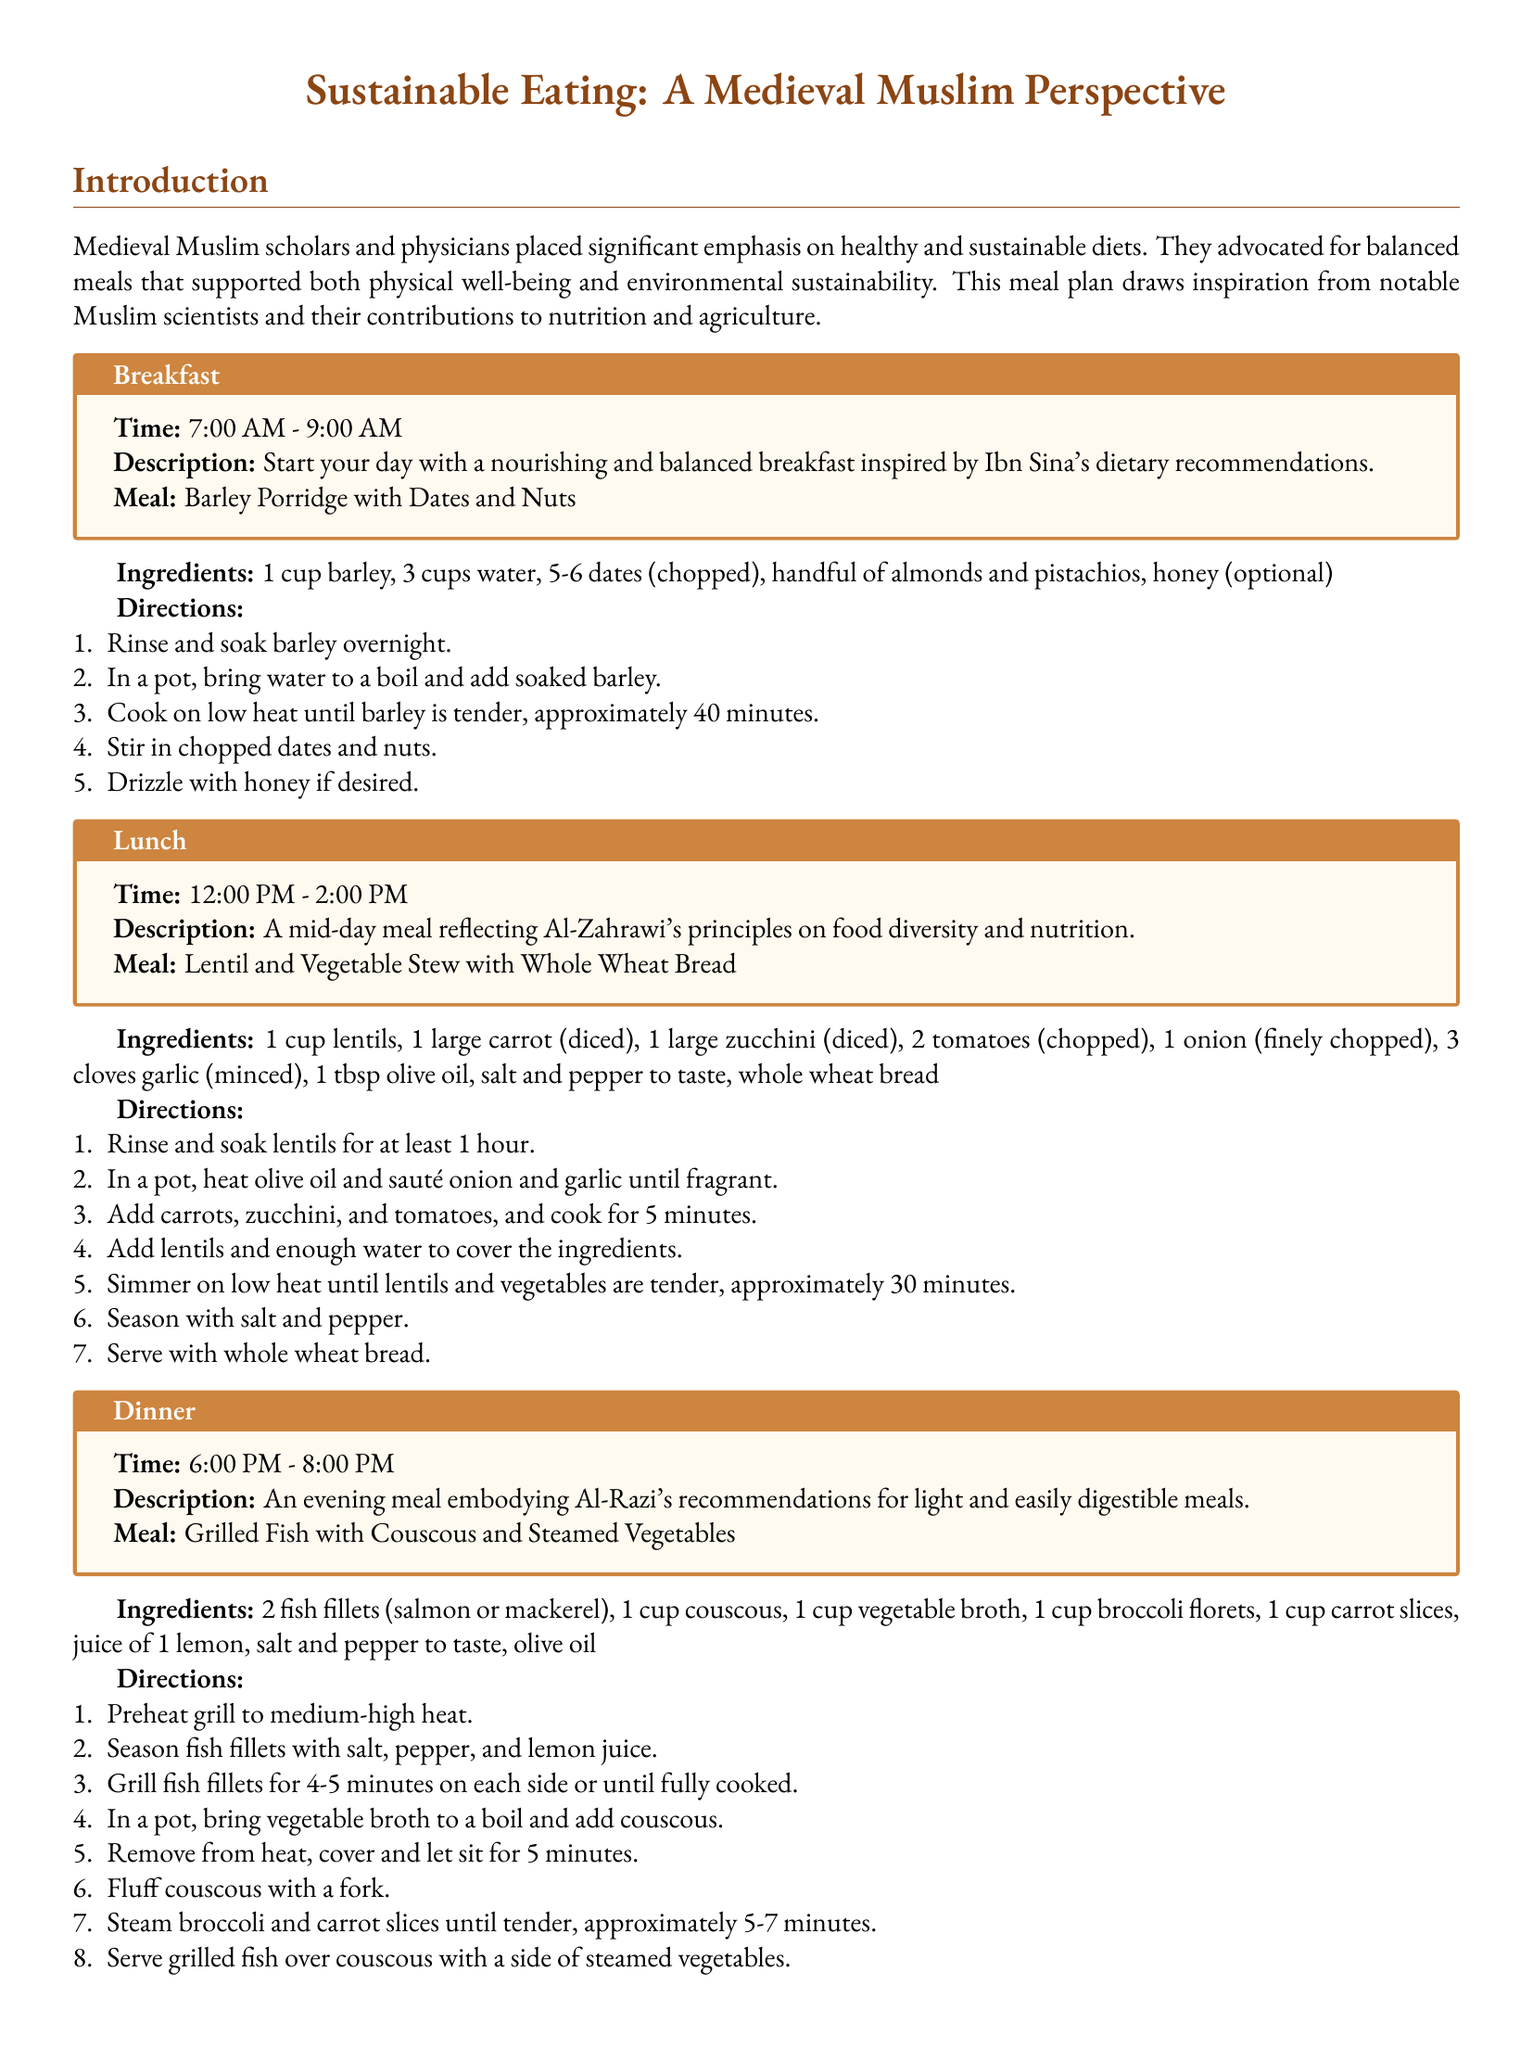what is the first meal of the day? The meal plan begins with breakfast, which is specified as the first meal of the day.
Answer: Barley Porridge with Dates and Nuts who is the scholar associated with the lunch meal? The lunch meal is reflective of Al-Zahrawi's principles on food diversity and nutrition, mentioned in the document.
Answer: Al-Zahrawi what time is dinner served? The document specifies that dinner is served between 6:00 PM and 8:00 PM.
Answer: 6:00 PM - 8:00 PM how long should lentils be soaked before cooking? The document states that lentils should be rinsed and soaked for at least 1 hour before cooking.
Answer: 1 hour which fish are recommended for the dinner meal? The document lists the types of fish that can be used for the dinner meal.
Answer: salmon or mackerel what type of bread is served with lunch? The lunch meal description specifies the type of bread accompanying the meal.
Answer: whole wheat bread which ingredient is optional for breakfast? The document indicates that one of the ingredients for breakfast can be omitted or included based on preference.
Answer: honey what is the total cooking time for barley porridge? The document states that barley should be cooked until tender, which takes approximately 40 minutes.
Answer: 40 minutes what does the meal plan emphasize according to the conclusion? The conclusion highlights a key theme regarding the dietary approach of the medieval Muslim scientists.
Answer: health and environmental stewardship 